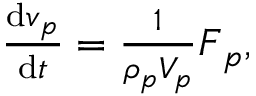<formula> <loc_0><loc_0><loc_500><loc_500>\begin{array} { r } { \frac { d v _ { p } } { d t } = \frac { 1 } { \rho _ { p } V _ { p } } F _ { p } , } \end{array}</formula> 